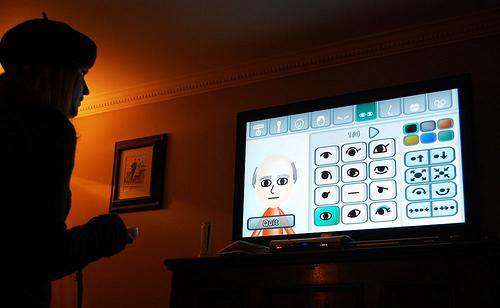Does the person making the avatar resemble the avatar?
Concise answer only. No. What game system is the person playing on?
Write a very short answer. Wii. What type of machine is this?
Give a very brief answer. Tv. What eye color has the player selected for their avatar?
Answer briefly. Black. 